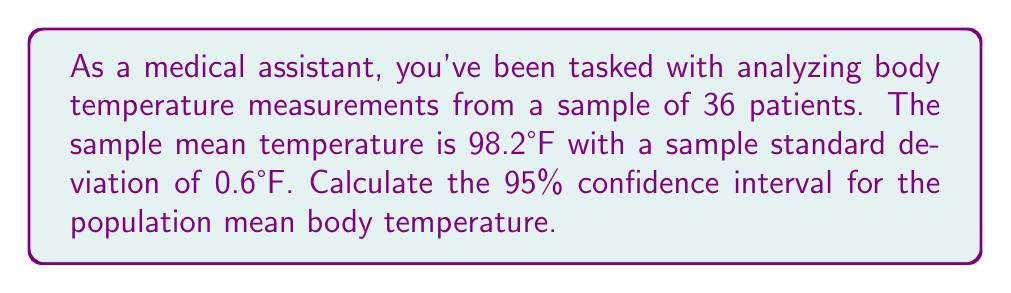What is the answer to this math problem? Let's approach this step-by-step:

1) We're dealing with a confidence interval for a population mean with unknown population standard deviation. We'll use the t-distribution.

2) Given information:
   - Sample size: $n = 36$
   - Sample mean: $\bar{x} = 98.2°F$
   - Sample standard deviation: $s = 0.6°F$
   - Confidence level: 95%

3) The formula for the confidence interval is:

   $$ \bar{x} \pm t_{\alpha/2, n-1} \cdot \frac{s}{\sqrt{n}} $$

   where $t_{\alpha/2, n-1}$ is the t-value with $n-1$ degrees of freedom.

4) For a 95% confidence interval, $\alpha = 0.05$, and $\alpha/2 = 0.025$

5) Degrees of freedom: $df = n - 1 = 36 - 1 = 35$

6) From t-table or calculator, $t_{0.025, 35} \approx 2.030$

7) Standard error: $SE = \frac{s}{\sqrt{n}} = \frac{0.6}{\sqrt{36}} = 0.1$

8) Margin of error: $ME = t_{\alpha/2, n-1} \cdot SE = 2.030 \cdot 0.1 = 0.203$

9) Therefore, the confidence interval is:

   $$ 98.2 \pm 0.203 $$
   $$ (97.997, 98.403) $$
Answer: (97.997°F, 98.403°F) 